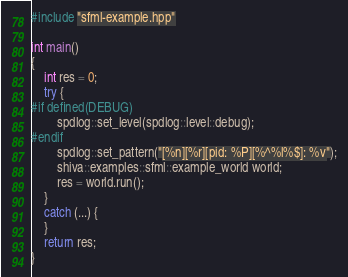Convert code to text. <code><loc_0><loc_0><loc_500><loc_500><_C++_>
#include "sfml-example.hpp"

int main()
{
    int res = 0;
    try {
#if defined(DEBUG)
        spdlog::set_level(spdlog::level::debug);
#endif
        spdlog::set_pattern("[%n][%r][pid: %P][%^%l%$]: %v");
        shiva::examples::sfml::example_world world;
        res = world.run();
    }
    catch (...) {
    }
    return res;
}</code> 